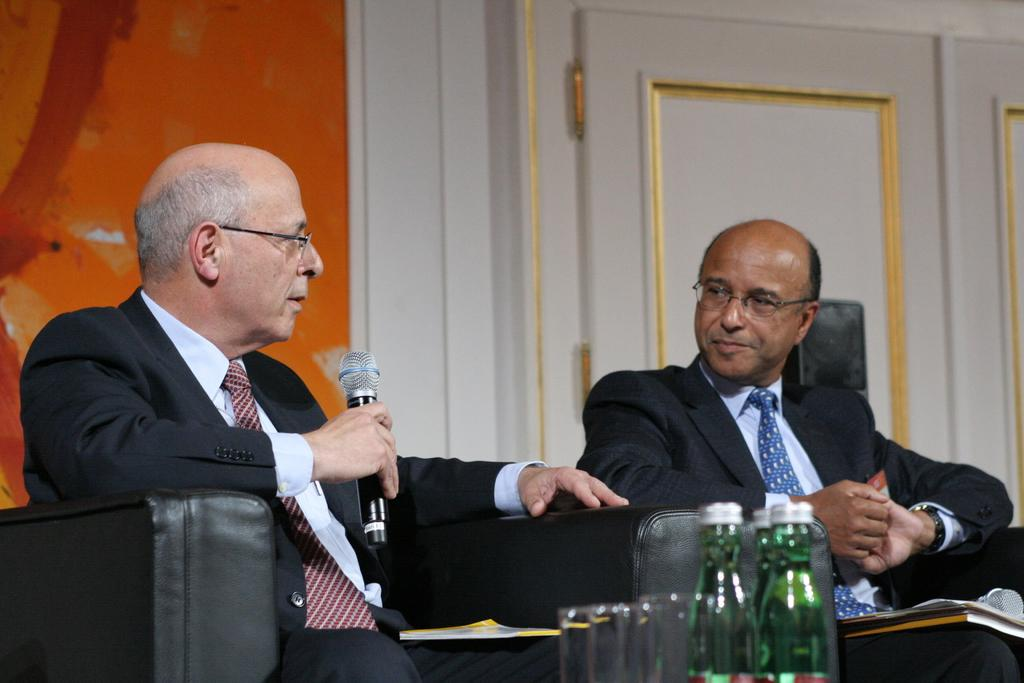How many people are in the image? There are two persons in the image. What are the persons doing in the image? The persons are sitting on a sofa. Can you describe the person on the left side? The person on the left side is holding a microphone. What objects can be seen in the front of the image? There are two bottles in the front of the image. What type of pizzas are being served during the summer event in the image? There are no pizzas or summer events present in the image; it features two persons sitting on a sofa with one holding a microphone and two bottles in the front. 